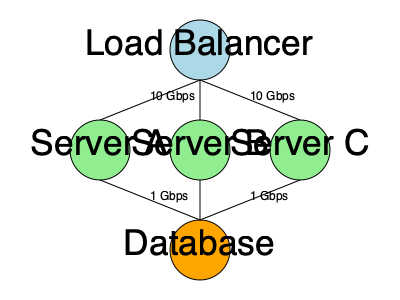Based on the network topology diagram, which component is most likely to become a bottleneck during high traffic periods, and why? To identify the potential bottleneck in this network topology, we need to analyze the components and their connections:

1. Load Balancer: Connected to servers A, B, and C with 10 Gbps links.
2. Servers A, B, and C: Each connected to the load balancer with 10 Gbps links and to the database with 1 Gbps links.
3. Database: Connected to all three servers with 1 Gbps links.

Step-by-step analysis:
1. The load balancer has high-speed connections (10 Gbps) to all servers, which allows for efficient distribution of incoming traffic.
2. Servers A, B, and C have high-speed connections to the load balancer, enabling them to receive traffic quickly.
3. However, the connections between the servers and the database are only 1 Gbps, which is significantly slower than the incoming connections.
4. During high traffic periods, the servers will likely need to frequently access the database to retrieve or store data.
5. The 1 Gbps connections to the database create a potential bottleneck, as they may not be able to handle the volume of data transfer required during peak traffic.
6. Additionally, the database itself is a single point where all data requests converge, further increasing the likelihood of it becoming a bottleneck.

Therefore, the database and its connections to the servers are the most likely components to become a bottleneck during high traffic periods. The mismatch between the high-speed incoming connections and the slower database connections can lead to data transfer delays and reduced overall system performance.
Answer: Database and its 1 Gbps connections 